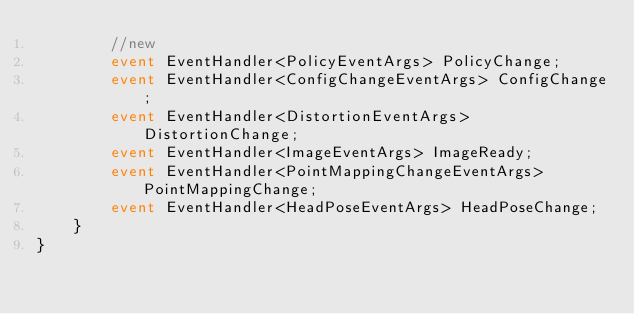<code> <loc_0><loc_0><loc_500><loc_500><_C#_>        //new
        event EventHandler<PolicyEventArgs> PolicyChange;
        event EventHandler<ConfigChangeEventArgs> ConfigChange;
        event EventHandler<DistortionEventArgs> DistortionChange;
        event EventHandler<ImageEventArgs> ImageReady;
        event EventHandler<PointMappingChangeEventArgs> PointMappingChange;
        event EventHandler<HeadPoseEventArgs> HeadPoseChange;
    }
}
</code> 